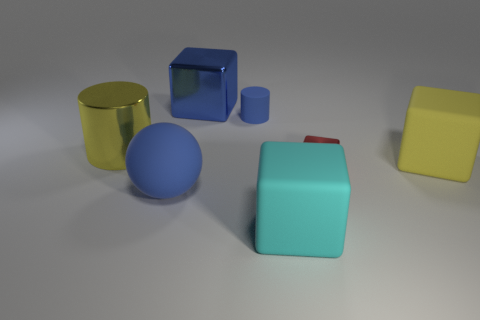Add 3 matte cubes. How many objects exist? 10 Subtract all cubes. How many objects are left? 3 Add 3 tiny rubber blocks. How many tiny rubber blocks exist? 3 Subtract 0 green balls. How many objects are left? 7 Subtract all large green matte things. Subtract all blue cylinders. How many objects are left? 6 Add 5 small matte objects. How many small matte objects are left? 6 